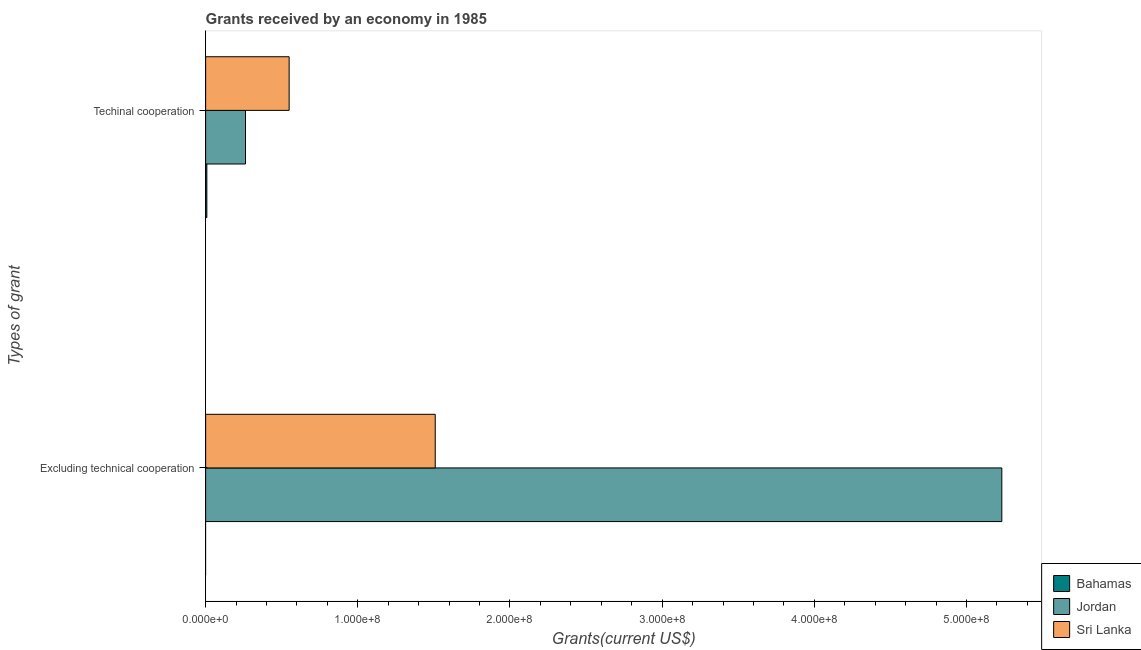How many different coloured bars are there?
Your answer should be compact. 3. How many groups of bars are there?
Keep it short and to the point. 2. Are the number of bars per tick equal to the number of legend labels?
Provide a succinct answer. No. How many bars are there on the 2nd tick from the top?
Provide a short and direct response. 2. How many bars are there on the 2nd tick from the bottom?
Your answer should be very brief. 3. What is the label of the 2nd group of bars from the top?
Ensure brevity in your answer.  Excluding technical cooperation. What is the amount of grants received(including technical cooperation) in Jordan?
Give a very brief answer. 2.62e+07. Across all countries, what is the maximum amount of grants received(excluding technical cooperation)?
Your answer should be compact. 5.23e+08. Across all countries, what is the minimum amount of grants received(excluding technical cooperation)?
Keep it short and to the point. 0. In which country was the amount of grants received(including technical cooperation) maximum?
Give a very brief answer. Sri Lanka. What is the total amount of grants received(excluding technical cooperation) in the graph?
Offer a terse response. 6.74e+08. What is the difference between the amount of grants received(including technical cooperation) in Jordan and that in Sri Lanka?
Your answer should be very brief. -2.87e+07. What is the difference between the amount of grants received(including technical cooperation) in Sri Lanka and the amount of grants received(excluding technical cooperation) in Bahamas?
Provide a short and direct response. 5.49e+07. What is the average amount of grants received(excluding technical cooperation) per country?
Your answer should be very brief. 2.25e+08. What is the difference between the amount of grants received(including technical cooperation) and amount of grants received(excluding technical cooperation) in Jordan?
Make the answer very short. -4.97e+08. What is the ratio of the amount of grants received(including technical cooperation) in Sri Lanka to that in Jordan?
Make the answer very short. 2.09. In how many countries, is the amount of grants received(including technical cooperation) greater than the average amount of grants received(including technical cooperation) taken over all countries?
Make the answer very short. 1. How many bars are there?
Give a very brief answer. 5. How many countries are there in the graph?
Ensure brevity in your answer.  3. What is the difference between two consecutive major ticks on the X-axis?
Your response must be concise. 1.00e+08. Does the graph contain any zero values?
Offer a very short reply. Yes. Does the graph contain grids?
Keep it short and to the point. No. Where does the legend appear in the graph?
Your answer should be compact. Bottom right. What is the title of the graph?
Offer a terse response. Grants received by an economy in 1985. What is the label or title of the X-axis?
Your response must be concise. Grants(current US$). What is the label or title of the Y-axis?
Offer a terse response. Types of grant. What is the Grants(current US$) of Jordan in Excluding technical cooperation?
Give a very brief answer. 5.23e+08. What is the Grants(current US$) in Sri Lanka in Excluding technical cooperation?
Your answer should be compact. 1.51e+08. What is the Grants(current US$) of Bahamas in Techinal cooperation?
Make the answer very short. 7.90e+05. What is the Grants(current US$) of Jordan in Techinal cooperation?
Offer a terse response. 2.62e+07. What is the Grants(current US$) in Sri Lanka in Techinal cooperation?
Give a very brief answer. 5.49e+07. Across all Types of grant, what is the maximum Grants(current US$) of Bahamas?
Your answer should be compact. 7.90e+05. Across all Types of grant, what is the maximum Grants(current US$) in Jordan?
Your answer should be compact. 5.23e+08. Across all Types of grant, what is the maximum Grants(current US$) of Sri Lanka?
Your answer should be very brief. 1.51e+08. Across all Types of grant, what is the minimum Grants(current US$) in Bahamas?
Ensure brevity in your answer.  0. Across all Types of grant, what is the minimum Grants(current US$) in Jordan?
Provide a succinct answer. 2.62e+07. Across all Types of grant, what is the minimum Grants(current US$) in Sri Lanka?
Your response must be concise. 5.49e+07. What is the total Grants(current US$) of Bahamas in the graph?
Ensure brevity in your answer.  7.90e+05. What is the total Grants(current US$) of Jordan in the graph?
Provide a short and direct response. 5.49e+08. What is the total Grants(current US$) in Sri Lanka in the graph?
Ensure brevity in your answer.  2.06e+08. What is the difference between the Grants(current US$) in Jordan in Excluding technical cooperation and that in Techinal cooperation?
Give a very brief answer. 4.97e+08. What is the difference between the Grants(current US$) in Sri Lanka in Excluding technical cooperation and that in Techinal cooperation?
Your answer should be compact. 9.60e+07. What is the difference between the Grants(current US$) of Jordan in Excluding technical cooperation and the Grants(current US$) of Sri Lanka in Techinal cooperation?
Ensure brevity in your answer.  4.68e+08. What is the average Grants(current US$) of Bahamas per Types of grant?
Make the answer very short. 3.95e+05. What is the average Grants(current US$) of Jordan per Types of grant?
Offer a terse response. 2.75e+08. What is the average Grants(current US$) of Sri Lanka per Types of grant?
Keep it short and to the point. 1.03e+08. What is the difference between the Grants(current US$) of Jordan and Grants(current US$) of Sri Lanka in Excluding technical cooperation?
Offer a terse response. 3.72e+08. What is the difference between the Grants(current US$) of Bahamas and Grants(current US$) of Jordan in Techinal cooperation?
Offer a very short reply. -2.54e+07. What is the difference between the Grants(current US$) of Bahamas and Grants(current US$) of Sri Lanka in Techinal cooperation?
Make the answer very short. -5.41e+07. What is the difference between the Grants(current US$) in Jordan and Grants(current US$) in Sri Lanka in Techinal cooperation?
Make the answer very short. -2.87e+07. What is the ratio of the Grants(current US$) of Jordan in Excluding technical cooperation to that in Techinal cooperation?
Give a very brief answer. 19.97. What is the ratio of the Grants(current US$) of Sri Lanka in Excluding technical cooperation to that in Techinal cooperation?
Ensure brevity in your answer.  2.75. What is the difference between the highest and the second highest Grants(current US$) in Jordan?
Make the answer very short. 4.97e+08. What is the difference between the highest and the second highest Grants(current US$) in Sri Lanka?
Your response must be concise. 9.60e+07. What is the difference between the highest and the lowest Grants(current US$) of Bahamas?
Your answer should be very brief. 7.90e+05. What is the difference between the highest and the lowest Grants(current US$) in Jordan?
Provide a short and direct response. 4.97e+08. What is the difference between the highest and the lowest Grants(current US$) of Sri Lanka?
Your answer should be very brief. 9.60e+07. 